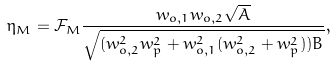<formula> <loc_0><loc_0><loc_500><loc_500>\eta _ { M } = \mathcal { F } _ { M } \frac { w _ { o , 1 } w _ { o , 2 } \sqrt { A } } { \sqrt { ( w _ { o , 2 } ^ { 2 } w _ { p } ^ { 2 } + w _ { o , 1 } ^ { 2 } ( w _ { o , 2 } ^ { 2 } + w _ { p } ^ { 2 } ) ) B } } ,</formula> 